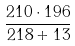Convert formula to latex. <formula><loc_0><loc_0><loc_500><loc_500>\frac { 2 1 0 \cdot 1 9 6 } { 2 1 8 + 1 3 }</formula> 